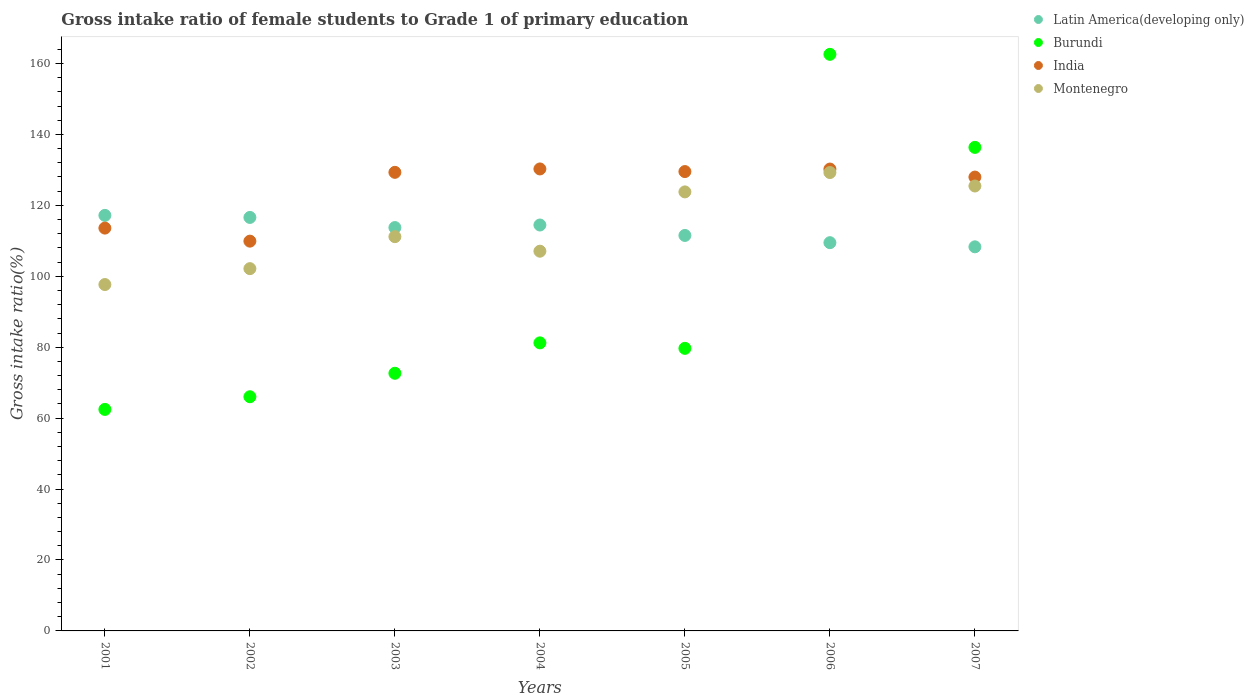What is the gross intake ratio in Burundi in 2007?
Ensure brevity in your answer.  136.34. Across all years, what is the maximum gross intake ratio in Montenegro?
Make the answer very short. 129.25. Across all years, what is the minimum gross intake ratio in Burundi?
Make the answer very short. 62.46. In which year was the gross intake ratio in Latin America(developing only) maximum?
Provide a short and direct response. 2001. In which year was the gross intake ratio in Burundi minimum?
Ensure brevity in your answer.  2001. What is the total gross intake ratio in Burundi in the graph?
Your answer should be very brief. 660.93. What is the difference between the gross intake ratio in India in 2005 and that in 2007?
Offer a terse response. 1.55. What is the difference between the gross intake ratio in Montenegro in 2006 and the gross intake ratio in Burundi in 2005?
Your response must be concise. 49.57. What is the average gross intake ratio in Montenegro per year?
Your answer should be very brief. 113.79. In the year 2001, what is the difference between the gross intake ratio in Montenegro and gross intake ratio in India?
Keep it short and to the point. -15.91. What is the ratio of the gross intake ratio in Montenegro in 2001 to that in 2004?
Offer a terse response. 0.91. Is the difference between the gross intake ratio in Montenegro in 2002 and 2006 greater than the difference between the gross intake ratio in India in 2002 and 2006?
Offer a very short reply. No. What is the difference between the highest and the second highest gross intake ratio in India?
Your answer should be very brief. 0.03. What is the difference between the highest and the lowest gross intake ratio in Latin America(developing only)?
Offer a very short reply. 8.87. In how many years, is the gross intake ratio in Montenegro greater than the average gross intake ratio in Montenegro taken over all years?
Provide a succinct answer. 3. Is the sum of the gross intake ratio in Burundi in 2002 and 2005 greater than the maximum gross intake ratio in Latin America(developing only) across all years?
Ensure brevity in your answer.  Yes. Is it the case that in every year, the sum of the gross intake ratio in Montenegro and gross intake ratio in Burundi  is greater than the gross intake ratio in Latin America(developing only)?
Offer a very short reply. Yes. Does the gross intake ratio in India monotonically increase over the years?
Your response must be concise. No. Is the gross intake ratio in Latin America(developing only) strictly less than the gross intake ratio in Montenegro over the years?
Make the answer very short. No. Are the values on the major ticks of Y-axis written in scientific E-notation?
Make the answer very short. No. Does the graph contain any zero values?
Your answer should be compact. No. How many legend labels are there?
Keep it short and to the point. 4. How are the legend labels stacked?
Your answer should be very brief. Vertical. What is the title of the graph?
Offer a terse response. Gross intake ratio of female students to Grade 1 of primary education. What is the label or title of the X-axis?
Offer a terse response. Years. What is the label or title of the Y-axis?
Your response must be concise. Gross intake ratio(%). What is the Gross intake ratio(%) in Latin America(developing only) in 2001?
Your answer should be very brief. 117.17. What is the Gross intake ratio(%) of Burundi in 2001?
Provide a short and direct response. 62.46. What is the Gross intake ratio(%) of India in 2001?
Provide a succinct answer. 113.58. What is the Gross intake ratio(%) in Montenegro in 2001?
Your answer should be very brief. 97.66. What is the Gross intake ratio(%) of Latin America(developing only) in 2002?
Provide a succinct answer. 116.59. What is the Gross intake ratio(%) of Burundi in 2002?
Ensure brevity in your answer.  66.03. What is the Gross intake ratio(%) in India in 2002?
Offer a terse response. 109.9. What is the Gross intake ratio(%) of Montenegro in 2002?
Give a very brief answer. 102.15. What is the Gross intake ratio(%) in Latin America(developing only) in 2003?
Provide a succinct answer. 113.73. What is the Gross intake ratio(%) in Burundi in 2003?
Offer a very short reply. 72.65. What is the Gross intake ratio(%) of India in 2003?
Give a very brief answer. 129.3. What is the Gross intake ratio(%) in Montenegro in 2003?
Make the answer very short. 111.16. What is the Gross intake ratio(%) in Latin America(developing only) in 2004?
Ensure brevity in your answer.  114.45. What is the Gross intake ratio(%) in Burundi in 2004?
Ensure brevity in your answer.  81.22. What is the Gross intake ratio(%) in India in 2004?
Give a very brief answer. 130.26. What is the Gross intake ratio(%) in Montenegro in 2004?
Ensure brevity in your answer.  107.06. What is the Gross intake ratio(%) in Latin America(developing only) in 2005?
Your answer should be very brief. 111.51. What is the Gross intake ratio(%) in Burundi in 2005?
Provide a short and direct response. 79.67. What is the Gross intake ratio(%) of India in 2005?
Provide a succinct answer. 129.52. What is the Gross intake ratio(%) in Montenegro in 2005?
Make the answer very short. 123.79. What is the Gross intake ratio(%) of Latin America(developing only) in 2006?
Your answer should be compact. 109.47. What is the Gross intake ratio(%) in Burundi in 2006?
Your answer should be compact. 162.58. What is the Gross intake ratio(%) in India in 2006?
Your answer should be very brief. 130.23. What is the Gross intake ratio(%) in Montenegro in 2006?
Your answer should be compact. 129.25. What is the Gross intake ratio(%) in Latin America(developing only) in 2007?
Ensure brevity in your answer.  108.3. What is the Gross intake ratio(%) in Burundi in 2007?
Your answer should be compact. 136.34. What is the Gross intake ratio(%) of India in 2007?
Your answer should be very brief. 127.97. What is the Gross intake ratio(%) in Montenegro in 2007?
Make the answer very short. 125.45. Across all years, what is the maximum Gross intake ratio(%) in Latin America(developing only)?
Your response must be concise. 117.17. Across all years, what is the maximum Gross intake ratio(%) of Burundi?
Offer a very short reply. 162.58. Across all years, what is the maximum Gross intake ratio(%) in India?
Ensure brevity in your answer.  130.26. Across all years, what is the maximum Gross intake ratio(%) in Montenegro?
Make the answer very short. 129.25. Across all years, what is the minimum Gross intake ratio(%) in Latin America(developing only)?
Your answer should be very brief. 108.3. Across all years, what is the minimum Gross intake ratio(%) in Burundi?
Make the answer very short. 62.46. Across all years, what is the minimum Gross intake ratio(%) of India?
Give a very brief answer. 109.9. Across all years, what is the minimum Gross intake ratio(%) of Montenegro?
Offer a very short reply. 97.66. What is the total Gross intake ratio(%) of Latin America(developing only) in the graph?
Offer a terse response. 791.21. What is the total Gross intake ratio(%) in Burundi in the graph?
Provide a succinct answer. 660.93. What is the total Gross intake ratio(%) in India in the graph?
Provide a succinct answer. 870.75. What is the total Gross intake ratio(%) of Montenegro in the graph?
Make the answer very short. 796.52. What is the difference between the Gross intake ratio(%) in Latin America(developing only) in 2001 and that in 2002?
Offer a terse response. 0.58. What is the difference between the Gross intake ratio(%) of Burundi in 2001 and that in 2002?
Provide a succinct answer. -3.57. What is the difference between the Gross intake ratio(%) in India in 2001 and that in 2002?
Ensure brevity in your answer.  3.68. What is the difference between the Gross intake ratio(%) of Montenegro in 2001 and that in 2002?
Your response must be concise. -4.48. What is the difference between the Gross intake ratio(%) of Latin America(developing only) in 2001 and that in 2003?
Your response must be concise. 3.44. What is the difference between the Gross intake ratio(%) in Burundi in 2001 and that in 2003?
Give a very brief answer. -10.19. What is the difference between the Gross intake ratio(%) of India in 2001 and that in 2003?
Keep it short and to the point. -15.72. What is the difference between the Gross intake ratio(%) of Montenegro in 2001 and that in 2003?
Give a very brief answer. -13.5. What is the difference between the Gross intake ratio(%) in Latin America(developing only) in 2001 and that in 2004?
Your response must be concise. 2.71. What is the difference between the Gross intake ratio(%) in Burundi in 2001 and that in 2004?
Provide a short and direct response. -18.76. What is the difference between the Gross intake ratio(%) in India in 2001 and that in 2004?
Your answer should be compact. -16.68. What is the difference between the Gross intake ratio(%) in Montenegro in 2001 and that in 2004?
Your answer should be very brief. -9.4. What is the difference between the Gross intake ratio(%) of Latin America(developing only) in 2001 and that in 2005?
Give a very brief answer. 5.66. What is the difference between the Gross intake ratio(%) of Burundi in 2001 and that in 2005?
Keep it short and to the point. -17.22. What is the difference between the Gross intake ratio(%) of India in 2001 and that in 2005?
Your answer should be compact. -15.94. What is the difference between the Gross intake ratio(%) in Montenegro in 2001 and that in 2005?
Your response must be concise. -26.12. What is the difference between the Gross intake ratio(%) of Latin America(developing only) in 2001 and that in 2006?
Offer a very short reply. 7.69. What is the difference between the Gross intake ratio(%) of Burundi in 2001 and that in 2006?
Give a very brief answer. -100.12. What is the difference between the Gross intake ratio(%) in India in 2001 and that in 2006?
Give a very brief answer. -16.65. What is the difference between the Gross intake ratio(%) of Montenegro in 2001 and that in 2006?
Your answer should be very brief. -31.58. What is the difference between the Gross intake ratio(%) in Latin America(developing only) in 2001 and that in 2007?
Provide a succinct answer. 8.87. What is the difference between the Gross intake ratio(%) in Burundi in 2001 and that in 2007?
Give a very brief answer. -73.88. What is the difference between the Gross intake ratio(%) of India in 2001 and that in 2007?
Provide a short and direct response. -14.39. What is the difference between the Gross intake ratio(%) in Montenegro in 2001 and that in 2007?
Your answer should be compact. -27.79. What is the difference between the Gross intake ratio(%) of Latin America(developing only) in 2002 and that in 2003?
Make the answer very short. 2.86. What is the difference between the Gross intake ratio(%) in Burundi in 2002 and that in 2003?
Keep it short and to the point. -6.62. What is the difference between the Gross intake ratio(%) of India in 2002 and that in 2003?
Give a very brief answer. -19.4. What is the difference between the Gross intake ratio(%) of Montenegro in 2002 and that in 2003?
Offer a very short reply. -9.02. What is the difference between the Gross intake ratio(%) in Latin America(developing only) in 2002 and that in 2004?
Provide a succinct answer. 2.13. What is the difference between the Gross intake ratio(%) of Burundi in 2002 and that in 2004?
Provide a short and direct response. -15.19. What is the difference between the Gross intake ratio(%) in India in 2002 and that in 2004?
Make the answer very short. -20.36. What is the difference between the Gross intake ratio(%) of Montenegro in 2002 and that in 2004?
Provide a succinct answer. -4.92. What is the difference between the Gross intake ratio(%) in Latin America(developing only) in 2002 and that in 2005?
Keep it short and to the point. 5.08. What is the difference between the Gross intake ratio(%) of Burundi in 2002 and that in 2005?
Provide a short and direct response. -13.65. What is the difference between the Gross intake ratio(%) of India in 2002 and that in 2005?
Provide a succinct answer. -19.62. What is the difference between the Gross intake ratio(%) in Montenegro in 2002 and that in 2005?
Ensure brevity in your answer.  -21.64. What is the difference between the Gross intake ratio(%) of Latin America(developing only) in 2002 and that in 2006?
Make the answer very short. 7.12. What is the difference between the Gross intake ratio(%) in Burundi in 2002 and that in 2006?
Make the answer very short. -96.55. What is the difference between the Gross intake ratio(%) in India in 2002 and that in 2006?
Keep it short and to the point. -20.33. What is the difference between the Gross intake ratio(%) of Montenegro in 2002 and that in 2006?
Offer a terse response. -27.1. What is the difference between the Gross intake ratio(%) of Latin America(developing only) in 2002 and that in 2007?
Provide a short and direct response. 8.29. What is the difference between the Gross intake ratio(%) in Burundi in 2002 and that in 2007?
Provide a succinct answer. -70.31. What is the difference between the Gross intake ratio(%) in India in 2002 and that in 2007?
Provide a succinct answer. -18.07. What is the difference between the Gross intake ratio(%) of Montenegro in 2002 and that in 2007?
Ensure brevity in your answer.  -23.3. What is the difference between the Gross intake ratio(%) of Latin America(developing only) in 2003 and that in 2004?
Keep it short and to the point. -0.72. What is the difference between the Gross intake ratio(%) of Burundi in 2003 and that in 2004?
Keep it short and to the point. -8.57. What is the difference between the Gross intake ratio(%) in India in 2003 and that in 2004?
Make the answer very short. -0.96. What is the difference between the Gross intake ratio(%) in Montenegro in 2003 and that in 2004?
Your response must be concise. 4.1. What is the difference between the Gross intake ratio(%) of Latin America(developing only) in 2003 and that in 2005?
Provide a short and direct response. 2.22. What is the difference between the Gross intake ratio(%) of Burundi in 2003 and that in 2005?
Offer a very short reply. -7.03. What is the difference between the Gross intake ratio(%) of India in 2003 and that in 2005?
Make the answer very short. -0.22. What is the difference between the Gross intake ratio(%) in Montenegro in 2003 and that in 2005?
Your answer should be compact. -12.62. What is the difference between the Gross intake ratio(%) of Latin America(developing only) in 2003 and that in 2006?
Ensure brevity in your answer.  4.26. What is the difference between the Gross intake ratio(%) in Burundi in 2003 and that in 2006?
Provide a succinct answer. -89.93. What is the difference between the Gross intake ratio(%) in India in 2003 and that in 2006?
Offer a very short reply. -0.93. What is the difference between the Gross intake ratio(%) in Montenegro in 2003 and that in 2006?
Keep it short and to the point. -18.08. What is the difference between the Gross intake ratio(%) in Latin America(developing only) in 2003 and that in 2007?
Keep it short and to the point. 5.43. What is the difference between the Gross intake ratio(%) in Burundi in 2003 and that in 2007?
Give a very brief answer. -63.69. What is the difference between the Gross intake ratio(%) of India in 2003 and that in 2007?
Your response must be concise. 1.34. What is the difference between the Gross intake ratio(%) in Montenegro in 2003 and that in 2007?
Offer a very short reply. -14.29. What is the difference between the Gross intake ratio(%) of Latin America(developing only) in 2004 and that in 2005?
Make the answer very short. 2.94. What is the difference between the Gross intake ratio(%) of Burundi in 2004 and that in 2005?
Give a very brief answer. 1.55. What is the difference between the Gross intake ratio(%) in India in 2004 and that in 2005?
Give a very brief answer. 0.74. What is the difference between the Gross intake ratio(%) of Montenegro in 2004 and that in 2005?
Offer a terse response. -16.72. What is the difference between the Gross intake ratio(%) in Latin America(developing only) in 2004 and that in 2006?
Provide a succinct answer. 4.98. What is the difference between the Gross intake ratio(%) of Burundi in 2004 and that in 2006?
Provide a short and direct response. -81.36. What is the difference between the Gross intake ratio(%) of India in 2004 and that in 2006?
Offer a terse response. 0.03. What is the difference between the Gross intake ratio(%) in Montenegro in 2004 and that in 2006?
Ensure brevity in your answer.  -22.18. What is the difference between the Gross intake ratio(%) in Latin America(developing only) in 2004 and that in 2007?
Keep it short and to the point. 6.15. What is the difference between the Gross intake ratio(%) of Burundi in 2004 and that in 2007?
Give a very brief answer. -55.12. What is the difference between the Gross intake ratio(%) in India in 2004 and that in 2007?
Your response must be concise. 2.29. What is the difference between the Gross intake ratio(%) of Montenegro in 2004 and that in 2007?
Keep it short and to the point. -18.39. What is the difference between the Gross intake ratio(%) of Latin America(developing only) in 2005 and that in 2006?
Your answer should be compact. 2.04. What is the difference between the Gross intake ratio(%) in Burundi in 2005 and that in 2006?
Provide a short and direct response. -82.9. What is the difference between the Gross intake ratio(%) of India in 2005 and that in 2006?
Ensure brevity in your answer.  -0.71. What is the difference between the Gross intake ratio(%) of Montenegro in 2005 and that in 2006?
Provide a short and direct response. -5.46. What is the difference between the Gross intake ratio(%) in Latin America(developing only) in 2005 and that in 2007?
Give a very brief answer. 3.21. What is the difference between the Gross intake ratio(%) in Burundi in 2005 and that in 2007?
Your answer should be compact. -56.67. What is the difference between the Gross intake ratio(%) of India in 2005 and that in 2007?
Your answer should be very brief. 1.55. What is the difference between the Gross intake ratio(%) of Montenegro in 2005 and that in 2007?
Keep it short and to the point. -1.66. What is the difference between the Gross intake ratio(%) of Latin America(developing only) in 2006 and that in 2007?
Provide a short and direct response. 1.17. What is the difference between the Gross intake ratio(%) of Burundi in 2006 and that in 2007?
Offer a very short reply. 26.24. What is the difference between the Gross intake ratio(%) in India in 2006 and that in 2007?
Offer a very short reply. 2.26. What is the difference between the Gross intake ratio(%) in Montenegro in 2006 and that in 2007?
Provide a succinct answer. 3.8. What is the difference between the Gross intake ratio(%) of Latin America(developing only) in 2001 and the Gross intake ratio(%) of Burundi in 2002?
Offer a very short reply. 51.14. What is the difference between the Gross intake ratio(%) in Latin America(developing only) in 2001 and the Gross intake ratio(%) in India in 2002?
Provide a succinct answer. 7.27. What is the difference between the Gross intake ratio(%) in Latin America(developing only) in 2001 and the Gross intake ratio(%) in Montenegro in 2002?
Provide a short and direct response. 15.02. What is the difference between the Gross intake ratio(%) in Burundi in 2001 and the Gross intake ratio(%) in India in 2002?
Your answer should be compact. -47.44. What is the difference between the Gross intake ratio(%) of Burundi in 2001 and the Gross intake ratio(%) of Montenegro in 2002?
Ensure brevity in your answer.  -39.69. What is the difference between the Gross intake ratio(%) in India in 2001 and the Gross intake ratio(%) in Montenegro in 2002?
Give a very brief answer. 11.43. What is the difference between the Gross intake ratio(%) in Latin America(developing only) in 2001 and the Gross intake ratio(%) in Burundi in 2003?
Your answer should be compact. 44.52. What is the difference between the Gross intake ratio(%) in Latin America(developing only) in 2001 and the Gross intake ratio(%) in India in 2003?
Your answer should be compact. -12.14. What is the difference between the Gross intake ratio(%) of Latin America(developing only) in 2001 and the Gross intake ratio(%) of Montenegro in 2003?
Offer a terse response. 6. What is the difference between the Gross intake ratio(%) of Burundi in 2001 and the Gross intake ratio(%) of India in 2003?
Make the answer very short. -66.85. What is the difference between the Gross intake ratio(%) in Burundi in 2001 and the Gross intake ratio(%) in Montenegro in 2003?
Offer a terse response. -48.71. What is the difference between the Gross intake ratio(%) in India in 2001 and the Gross intake ratio(%) in Montenegro in 2003?
Provide a short and direct response. 2.42. What is the difference between the Gross intake ratio(%) of Latin America(developing only) in 2001 and the Gross intake ratio(%) of Burundi in 2004?
Offer a very short reply. 35.95. What is the difference between the Gross intake ratio(%) of Latin America(developing only) in 2001 and the Gross intake ratio(%) of India in 2004?
Offer a very short reply. -13.09. What is the difference between the Gross intake ratio(%) in Latin America(developing only) in 2001 and the Gross intake ratio(%) in Montenegro in 2004?
Ensure brevity in your answer.  10.1. What is the difference between the Gross intake ratio(%) of Burundi in 2001 and the Gross intake ratio(%) of India in 2004?
Offer a very short reply. -67.8. What is the difference between the Gross intake ratio(%) in Burundi in 2001 and the Gross intake ratio(%) in Montenegro in 2004?
Make the answer very short. -44.61. What is the difference between the Gross intake ratio(%) in India in 2001 and the Gross intake ratio(%) in Montenegro in 2004?
Your answer should be compact. 6.51. What is the difference between the Gross intake ratio(%) of Latin America(developing only) in 2001 and the Gross intake ratio(%) of Burundi in 2005?
Provide a short and direct response. 37.49. What is the difference between the Gross intake ratio(%) in Latin America(developing only) in 2001 and the Gross intake ratio(%) in India in 2005?
Provide a succinct answer. -12.35. What is the difference between the Gross intake ratio(%) of Latin America(developing only) in 2001 and the Gross intake ratio(%) of Montenegro in 2005?
Keep it short and to the point. -6.62. What is the difference between the Gross intake ratio(%) of Burundi in 2001 and the Gross intake ratio(%) of India in 2005?
Offer a terse response. -67.06. What is the difference between the Gross intake ratio(%) of Burundi in 2001 and the Gross intake ratio(%) of Montenegro in 2005?
Keep it short and to the point. -61.33. What is the difference between the Gross intake ratio(%) in India in 2001 and the Gross intake ratio(%) in Montenegro in 2005?
Your answer should be compact. -10.21. What is the difference between the Gross intake ratio(%) in Latin America(developing only) in 2001 and the Gross intake ratio(%) in Burundi in 2006?
Your answer should be compact. -45.41. What is the difference between the Gross intake ratio(%) of Latin America(developing only) in 2001 and the Gross intake ratio(%) of India in 2006?
Your answer should be compact. -13.06. What is the difference between the Gross intake ratio(%) in Latin America(developing only) in 2001 and the Gross intake ratio(%) in Montenegro in 2006?
Your answer should be compact. -12.08. What is the difference between the Gross intake ratio(%) in Burundi in 2001 and the Gross intake ratio(%) in India in 2006?
Your response must be concise. -67.77. What is the difference between the Gross intake ratio(%) in Burundi in 2001 and the Gross intake ratio(%) in Montenegro in 2006?
Your response must be concise. -66.79. What is the difference between the Gross intake ratio(%) in India in 2001 and the Gross intake ratio(%) in Montenegro in 2006?
Your answer should be very brief. -15.67. What is the difference between the Gross intake ratio(%) in Latin America(developing only) in 2001 and the Gross intake ratio(%) in Burundi in 2007?
Provide a succinct answer. -19.17. What is the difference between the Gross intake ratio(%) in Latin America(developing only) in 2001 and the Gross intake ratio(%) in India in 2007?
Offer a very short reply. -10.8. What is the difference between the Gross intake ratio(%) in Latin America(developing only) in 2001 and the Gross intake ratio(%) in Montenegro in 2007?
Give a very brief answer. -8.28. What is the difference between the Gross intake ratio(%) of Burundi in 2001 and the Gross intake ratio(%) of India in 2007?
Keep it short and to the point. -65.51. What is the difference between the Gross intake ratio(%) of Burundi in 2001 and the Gross intake ratio(%) of Montenegro in 2007?
Make the answer very short. -62.99. What is the difference between the Gross intake ratio(%) in India in 2001 and the Gross intake ratio(%) in Montenegro in 2007?
Keep it short and to the point. -11.87. What is the difference between the Gross intake ratio(%) of Latin America(developing only) in 2002 and the Gross intake ratio(%) of Burundi in 2003?
Make the answer very short. 43.94. What is the difference between the Gross intake ratio(%) of Latin America(developing only) in 2002 and the Gross intake ratio(%) of India in 2003?
Offer a terse response. -12.72. What is the difference between the Gross intake ratio(%) in Latin America(developing only) in 2002 and the Gross intake ratio(%) in Montenegro in 2003?
Provide a short and direct response. 5.42. What is the difference between the Gross intake ratio(%) of Burundi in 2002 and the Gross intake ratio(%) of India in 2003?
Your answer should be compact. -63.28. What is the difference between the Gross intake ratio(%) in Burundi in 2002 and the Gross intake ratio(%) in Montenegro in 2003?
Make the answer very short. -45.14. What is the difference between the Gross intake ratio(%) of India in 2002 and the Gross intake ratio(%) of Montenegro in 2003?
Make the answer very short. -1.26. What is the difference between the Gross intake ratio(%) of Latin America(developing only) in 2002 and the Gross intake ratio(%) of Burundi in 2004?
Ensure brevity in your answer.  35.37. What is the difference between the Gross intake ratio(%) of Latin America(developing only) in 2002 and the Gross intake ratio(%) of India in 2004?
Your answer should be very brief. -13.67. What is the difference between the Gross intake ratio(%) of Latin America(developing only) in 2002 and the Gross intake ratio(%) of Montenegro in 2004?
Offer a terse response. 9.52. What is the difference between the Gross intake ratio(%) in Burundi in 2002 and the Gross intake ratio(%) in India in 2004?
Keep it short and to the point. -64.23. What is the difference between the Gross intake ratio(%) in Burundi in 2002 and the Gross intake ratio(%) in Montenegro in 2004?
Offer a terse response. -41.04. What is the difference between the Gross intake ratio(%) of India in 2002 and the Gross intake ratio(%) of Montenegro in 2004?
Make the answer very short. 2.84. What is the difference between the Gross intake ratio(%) of Latin America(developing only) in 2002 and the Gross intake ratio(%) of Burundi in 2005?
Your answer should be very brief. 36.91. What is the difference between the Gross intake ratio(%) in Latin America(developing only) in 2002 and the Gross intake ratio(%) in India in 2005?
Offer a terse response. -12.93. What is the difference between the Gross intake ratio(%) in Latin America(developing only) in 2002 and the Gross intake ratio(%) in Montenegro in 2005?
Your response must be concise. -7.2. What is the difference between the Gross intake ratio(%) in Burundi in 2002 and the Gross intake ratio(%) in India in 2005?
Give a very brief answer. -63.49. What is the difference between the Gross intake ratio(%) of Burundi in 2002 and the Gross intake ratio(%) of Montenegro in 2005?
Your response must be concise. -57.76. What is the difference between the Gross intake ratio(%) in India in 2002 and the Gross intake ratio(%) in Montenegro in 2005?
Your answer should be very brief. -13.89. What is the difference between the Gross intake ratio(%) in Latin America(developing only) in 2002 and the Gross intake ratio(%) in Burundi in 2006?
Your answer should be very brief. -45.99. What is the difference between the Gross intake ratio(%) of Latin America(developing only) in 2002 and the Gross intake ratio(%) of India in 2006?
Your answer should be very brief. -13.64. What is the difference between the Gross intake ratio(%) in Latin America(developing only) in 2002 and the Gross intake ratio(%) in Montenegro in 2006?
Offer a terse response. -12.66. What is the difference between the Gross intake ratio(%) of Burundi in 2002 and the Gross intake ratio(%) of India in 2006?
Offer a very short reply. -64.2. What is the difference between the Gross intake ratio(%) in Burundi in 2002 and the Gross intake ratio(%) in Montenegro in 2006?
Give a very brief answer. -63.22. What is the difference between the Gross intake ratio(%) in India in 2002 and the Gross intake ratio(%) in Montenegro in 2006?
Your answer should be compact. -19.35. What is the difference between the Gross intake ratio(%) of Latin America(developing only) in 2002 and the Gross intake ratio(%) of Burundi in 2007?
Offer a very short reply. -19.75. What is the difference between the Gross intake ratio(%) in Latin America(developing only) in 2002 and the Gross intake ratio(%) in India in 2007?
Offer a terse response. -11.38. What is the difference between the Gross intake ratio(%) of Latin America(developing only) in 2002 and the Gross intake ratio(%) of Montenegro in 2007?
Your response must be concise. -8.86. What is the difference between the Gross intake ratio(%) of Burundi in 2002 and the Gross intake ratio(%) of India in 2007?
Give a very brief answer. -61.94. What is the difference between the Gross intake ratio(%) in Burundi in 2002 and the Gross intake ratio(%) in Montenegro in 2007?
Your answer should be very brief. -59.42. What is the difference between the Gross intake ratio(%) of India in 2002 and the Gross intake ratio(%) of Montenegro in 2007?
Offer a terse response. -15.55. What is the difference between the Gross intake ratio(%) of Latin America(developing only) in 2003 and the Gross intake ratio(%) of Burundi in 2004?
Your answer should be compact. 32.51. What is the difference between the Gross intake ratio(%) in Latin America(developing only) in 2003 and the Gross intake ratio(%) in India in 2004?
Give a very brief answer. -16.53. What is the difference between the Gross intake ratio(%) in Latin America(developing only) in 2003 and the Gross intake ratio(%) in Montenegro in 2004?
Your answer should be very brief. 6.67. What is the difference between the Gross intake ratio(%) of Burundi in 2003 and the Gross intake ratio(%) of India in 2004?
Your answer should be very brief. -57.61. What is the difference between the Gross intake ratio(%) of Burundi in 2003 and the Gross intake ratio(%) of Montenegro in 2004?
Your answer should be compact. -34.42. What is the difference between the Gross intake ratio(%) of India in 2003 and the Gross intake ratio(%) of Montenegro in 2004?
Ensure brevity in your answer.  22.24. What is the difference between the Gross intake ratio(%) in Latin America(developing only) in 2003 and the Gross intake ratio(%) in Burundi in 2005?
Provide a succinct answer. 34.06. What is the difference between the Gross intake ratio(%) in Latin America(developing only) in 2003 and the Gross intake ratio(%) in India in 2005?
Offer a very short reply. -15.79. What is the difference between the Gross intake ratio(%) of Latin America(developing only) in 2003 and the Gross intake ratio(%) of Montenegro in 2005?
Offer a very short reply. -10.06. What is the difference between the Gross intake ratio(%) of Burundi in 2003 and the Gross intake ratio(%) of India in 2005?
Provide a succinct answer. -56.87. What is the difference between the Gross intake ratio(%) in Burundi in 2003 and the Gross intake ratio(%) in Montenegro in 2005?
Ensure brevity in your answer.  -51.14. What is the difference between the Gross intake ratio(%) of India in 2003 and the Gross intake ratio(%) of Montenegro in 2005?
Make the answer very short. 5.52. What is the difference between the Gross intake ratio(%) of Latin America(developing only) in 2003 and the Gross intake ratio(%) of Burundi in 2006?
Provide a short and direct response. -48.85. What is the difference between the Gross intake ratio(%) of Latin America(developing only) in 2003 and the Gross intake ratio(%) of India in 2006?
Provide a succinct answer. -16.5. What is the difference between the Gross intake ratio(%) of Latin America(developing only) in 2003 and the Gross intake ratio(%) of Montenegro in 2006?
Offer a terse response. -15.52. What is the difference between the Gross intake ratio(%) of Burundi in 2003 and the Gross intake ratio(%) of India in 2006?
Your response must be concise. -57.58. What is the difference between the Gross intake ratio(%) of Burundi in 2003 and the Gross intake ratio(%) of Montenegro in 2006?
Make the answer very short. -56.6. What is the difference between the Gross intake ratio(%) of India in 2003 and the Gross intake ratio(%) of Montenegro in 2006?
Give a very brief answer. 0.06. What is the difference between the Gross intake ratio(%) of Latin America(developing only) in 2003 and the Gross intake ratio(%) of Burundi in 2007?
Keep it short and to the point. -22.61. What is the difference between the Gross intake ratio(%) of Latin America(developing only) in 2003 and the Gross intake ratio(%) of India in 2007?
Your response must be concise. -14.24. What is the difference between the Gross intake ratio(%) of Latin America(developing only) in 2003 and the Gross intake ratio(%) of Montenegro in 2007?
Your response must be concise. -11.72. What is the difference between the Gross intake ratio(%) in Burundi in 2003 and the Gross intake ratio(%) in India in 2007?
Your answer should be very brief. -55.32. What is the difference between the Gross intake ratio(%) of Burundi in 2003 and the Gross intake ratio(%) of Montenegro in 2007?
Make the answer very short. -52.8. What is the difference between the Gross intake ratio(%) in India in 2003 and the Gross intake ratio(%) in Montenegro in 2007?
Give a very brief answer. 3.85. What is the difference between the Gross intake ratio(%) in Latin America(developing only) in 2004 and the Gross intake ratio(%) in Burundi in 2005?
Ensure brevity in your answer.  34.78. What is the difference between the Gross intake ratio(%) in Latin America(developing only) in 2004 and the Gross intake ratio(%) in India in 2005?
Offer a terse response. -15.07. What is the difference between the Gross intake ratio(%) in Latin America(developing only) in 2004 and the Gross intake ratio(%) in Montenegro in 2005?
Your answer should be compact. -9.34. What is the difference between the Gross intake ratio(%) of Burundi in 2004 and the Gross intake ratio(%) of India in 2005?
Your answer should be compact. -48.3. What is the difference between the Gross intake ratio(%) in Burundi in 2004 and the Gross intake ratio(%) in Montenegro in 2005?
Your answer should be compact. -42.57. What is the difference between the Gross intake ratio(%) of India in 2004 and the Gross intake ratio(%) of Montenegro in 2005?
Your answer should be very brief. 6.47. What is the difference between the Gross intake ratio(%) in Latin America(developing only) in 2004 and the Gross intake ratio(%) in Burundi in 2006?
Give a very brief answer. -48.12. What is the difference between the Gross intake ratio(%) of Latin America(developing only) in 2004 and the Gross intake ratio(%) of India in 2006?
Ensure brevity in your answer.  -15.78. What is the difference between the Gross intake ratio(%) in Latin America(developing only) in 2004 and the Gross intake ratio(%) in Montenegro in 2006?
Offer a very short reply. -14.79. What is the difference between the Gross intake ratio(%) in Burundi in 2004 and the Gross intake ratio(%) in India in 2006?
Provide a succinct answer. -49.01. What is the difference between the Gross intake ratio(%) in Burundi in 2004 and the Gross intake ratio(%) in Montenegro in 2006?
Your answer should be very brief. -48.03. What is the difference between the Gross intake ratio(%) of India in 2004 and the Gross intake ratio(%) of Montenegro in 2006?
Your answer should be compact. 1.01. What is the difference between the Gross intake ratio(%) of Latin America(developing only) in 2004 and the Gross intake ratio(%) of Burundi in 2007?
Offer a terse response. -21.89. What is the difference between the Gross intake ratio(%) of Latin America(developing only) in 2004 and the Gross intake ratio(%) of India in 2007?
Make the answer very short. -13.51. What is the difference between the Gross intake ratio(%) of Latin America(developing only) in 2004 and the Gross intake ratio(%) of Montenegro in 2007?
Provide a short and direct response. -11. What is the difference between the Gross intake ratio(%) of Burundi in 2004 and the Gross intake ratio(%) of India in 2007?
Your answer should be very brief. -46.75. What is the difference between the Gross intake ratio(%) of Burundi in 2004 and the Gross intake ratio(%) of Montenegro in 2007?
Make the answer very short. -44.23. What is the difference between the Gross intake ratio(%) of India in 2004 and the Gross intake ratio(%) of Montenegro in 2007?
Make the answer very short. 4.81. What is the difference between the Gross intake ratio(%) of Latin America(developing only) in 2005 and the Gross intake ratio(%) of Burundi in 2006?
Provide a short and direct response. -51.07. What is the difference between the Gross intake ratio(%) of Latin America(developing only) in 2005 and the Gross intake ratio(%) of India in 2006?
Keep it short and to the point. -18.72. What is the difference between the Gross intake ratio(%) in Latin America(developing only) in 2005 and the Gross intake ratio(%) in Montenegro in 2006?
Make the answer very short. -17.74. What is the difference between the Gross intake ratio(%) of Burundi in 2005 and the Gross intake ratio(%) of India in 2006?
Make the answer very short. -50.56. What is the difference between the Gross intake ratio(%) in Burundi in 2005 and the Gross intake ratio(%) in Montenegro in 2006?
Provide a short and direct response. -49.57. What is the difference between the Gross intake ratio(%) of India in 2005 and the Gross intake ratio(%) of Montenegro in 2006?
Provide a short and direct response. 0.27. What is the difference between the Gross intake ratio(%) of Latin America(developing only) in 2005 and the Gross intake ratio(%) of Burundi in 2007?
Give a very brief answer. -24.83. What is the difference between the Gross intake ratio(%) of Latin America(developing only) in 2005 and the Gross intake ratio(%) of India in 2007?
Provide a succinct answer. -16.46. What is the difference between the Gross intake ratio(%) of Latin America(developing only) in 2005 and the Gross intake ratio(%) of Montenegro in 2007?
Your answer should be very brief. -13.94. What is the difference between the Gross intake ratio(%) of Burundi in 2005 and the Gross intake ratio(%) of India in 2007?
Give a very brief answer. -48.29. What is the difference between the Gross intake ratio(%) in Burundi in 2005 and the Gross intake ratio(%) in Montenegro in 2007?
Ensure brevity in your answer.  -45.78. What is the difference between the Gross intake ratio(%) of India in 2005 and the Gross intake ratio(%) of Montenegro in 2007?
Make the answer very short. 4.07. What is the difference between the Gross intake ratio(%) in Latin America(developing only) in 2006 and the Gross intake ratio(%) in Burundi in 2007?
Give a very brief answer. -26.87. What is the difference between the Gross intake ratio(%) of Latin America(developing only) in 2006 and the Gross intake ratio(%) of India in 2007?
Provide a short and direct response. -18.5. What is the difference between the Gross intake ratio(%) in Latin America(developing only) in 2006 and the Gross intake ratio(%) in Montenegro in 2007?
Offer a very short reply. -15.98. What is the difference between the Gross intake ratio(%) of Burundi in 2006 and the Gross intake ratio(%) of India in 2007?
Ensure brevity in your answer.  34.61. What is the difference between the Gross intake ratio(%) of Burundi in 2006 and the Gross intake ratio(%) of Montenegro in 2007?
Keep it short and to the point. 37.13. What is the difference between the Gross intake ratio(%) in India in 2006 and the Gross intake ratio(%) in Montenegro in 2007?
Your response must be concise. 4.78. What is the average Gross intake ratio(%) in Latin America(developing only) per year?
Your response must be concise. 113.03. What is the average Gross intake ratio(%) of Burundi per year?
Offer a very short reply. 94.42. What is the average Gross intake ratio(%) of India per year?
Your response must be concise. 124.39. What is the average Gross intake ratio(%) of Montenegro per year?
Keep it short and to the point. 113.79. In the year 2001, what is the difference between the Gross intake ratio(%) of Latin America(developing only) and Gross intake ratio(%) of Burundi?
Provide a short and direct response. 54.71. In the year 2001, what is the difference between the Gross intake ratio(%) of Latin America(developing only) and Gross intake ratio(%) of India?
Make the answer very short. 3.59. In the year 2001, what is the difference between the Gross intake ratio(%) in Latin America(developing only) and Gross intake ratio(%) in Montenegro?
Offer a very short reply. 19.5. In the year 2001, what is the difference between the Gross intake ratio(%) of Burundi and Gross intake ratio(%) of India?
Provide a short and direct response. -51.12. In the year 2001, what is the difference between the Gross intake ratio(%) in Burundi and Gross intake ratio(%) in Montenegro?
Keep it short and to the point. -35.21. In the year 2001, what is the difference between the Gross intake ratio(%) in India and Gross intake ratio(%) in Montenegro?
Give a very brief answer. 15.91. In the year 2002, what is the difference between the Gross intake ratio(%) of Latin America(developing only) and Gross intake ratio(%) of Burundi?
Provide a short and direct response. 50.56. In the year 2002, what is the difference between the Gross intake ratio(%) in Latin America(developing only) and Gross intake ratio(%) in India?
Your answer should be very brief. 6.69. In the year 2002, what is the difference between the Gross intake ratio(%) of Latin America(developing only) and Gross intake ratio(%) of Montenegro?
Offer a terse response. 14.44. In the year 2002, what is the difference between the Gross intake ratio(%) of Burundi and Gross intake ratio(%) of India?
Keep it short and to the point. -43.87. In the year 2002, what is the difference between the Gross intake ratio(%) in Burundi and Gross intake ratio(%) in Montenegro?
Keep it short and to the point. -36.12. In the year 2002, what is the difference between the Gross intake ratio(%) of India and Gross intake ratio(%) of Montenegro?
Keep it short and to the point. 7.75. In the year 2003, what is the difference between the Gross intake ratio(%) of Latin America(developing only) and Gross intake ratio(%) of Burundi?
Ensure brevity in your answer.  41.08. In the year 2003, what is the difference between the Gross intake ratio(%) in Latin America(developing only) and Gross intake ratio(%) in India?
Your answer should be compact. -15.57. In the year 2003, what is the difference between the Gross intake ratio(%) of Latin America(developing only) and Gross intake ratio(%) of Montenegro?
Ensure brevity in your answer.  2.57. In the year 2003, what is the difference between the Gross intake ratio(%) in Burundi and Gross intake ratio(%) in India?
Ensure brevity in your answer.  -56.66. In the year 2003, what is the difference between the Gross intake ratio(%) of Burundi and Gross intake ratio(%) of Montenegro?
Your response must be concise. -38.52. In the year 2003, what is the difference between the Gross intake ratio(%) of India and Gross intake ratio(%) of Montenegro?
Your answer should be compact. 18.14. In the year 2004, what is the difference between the Gross intake ratio(%) of Latin America(developing only) and Gross intake ratio(%) of Burundi?
Give a very brief answer. 33.23. In the year 2004, what is the difference between the Gross intake ratio(%) of Latin America(developing only) and Gross intake ratio(%) of India?
Make the answer very short. -15.81. In the year 2004, what is the difference between the Gross intake ratio(%) of Latin America(developing only) and Gross intake ratio(%) of Montenegro?
Your answer should be very brief. 7.39. In the year 2004, what is the difference between the Gross intake ratio(%) of Burundi and Gross intake ratio(%) of India?
Your answer should be compact. -49.04. In the year 2004, what is the difference between the Gross intake ratio(%) of Burundi and Gross intake ratio(%) of Montenegro?
Provide a succinct answer. -25.85. In the year 2004, what is the difference between the Gross intake ratio(%) in India and Gross intake ratio(%) in Montenegro?
Keep it short and to the point. 23.19. In the year 2005, what is the difference between the Gross intake ratio(%) in Latin America(developing only) and Gross intake ratio(%) in Burundi?
Your answer should be very brief. 31.84. In the year 2005, what is the difference between the Gross intake ratio(%) of Latin America(developing only) and Gross intake ratio(%) of India?
Your answer should be very brief. -18.01. In the year 2005, what is the difference between the Gross intake ratio(%) in Latin America(developing only) and Gross intake ratio(%) in Montenegro?
Make the answer very short. -12.28. In the year 2005, what is the difference between the Gross intake ratio(%) of Burundi and Gross intake ratio(%) of India?
Keep it short and to the point. -49.85. In the year 2005, what is the difference between the Gross intake ratio(%) in Burundi and Gross intake ratio(%) in Montenegro?
Your answer should be very brief. -44.11. In the year 2005, what is the difference between the Gross intake ratio(%) in India and Gross intake ratio(%) in Montenegro?
Your answer should be compact. 5.73. In the year 2006, what is the difference between the Gross intake ratio(%) of Latin America(developing only) and Gross intake ratio(%) of Burundi?
Ensure brevity in your answer.  -53.11. In the year 2006, what is the difference between the Gross intake ratio(%) in Latin America(developing only) and Gross intake ratio(%) in India?
Your response must be concise. -20.76. In the year 2006, what is the difference between the Gross intake ratio(%) of Latin America(developing only) and Gross intake ratio(%) of Montenegro?
Offer a terse response. -19.78. In the year 2006, what is the difference between the Gross intake ratio(%) of Burundi and Gross intake ratio(%) of India?
Provide a short and direct response. 32.35. In the year 2006, what is the difference between the Gross intake ratio(%) in Burundi and Gross intake ratio(%) in Montenegro?
Ensure brevity in your answer.  33.33. In the year 2006, what is the difference between the Gross intake ratio(%) in India and Gross intake ratio(%) in Montenegro?
Ensure brevity in your answer.  0.98. In the year 2007, what is the difference between the Gross intake ratio(%) in Latin America(developing only) and Gross intake ratio(%) in Burundi?
Your answer should be compact. -28.04. In the year 2007, what is the difference between the Gross intake ratio(%) of Latin America(developing only) and Gross intake ratio(%) of India?
Your answer should be very brief. -19.67. In the year 2007, what is the difference between the Gross intake ratio(%) of Latin America(developing only) and Gross intake ratio(%) of Montenegro?
Offer a very short reply. -17.15. In the year 2007, what is the difference between the Gross intake ratio(%) of Burundi and Gross intake ratio(%) of India?
Your answer should be very brief. 8.37. In the year 2007, what is the difference between the Gross intake ratio(%) of Burundi and Gross intake ratio(%) of Montenegro?
Offer a very short reply. 10.89. In the year 2007, what is the difference between the Gross intake ratio(%) in India and Gross intake ratio(%) in Montenegro?
Make the answer very short. 2.52. What is the ratio of the Gross intake ratio(%) in Burundi in 2001 to that in 2002?
Ensure brevity in your answer.  0.95. What is the ratio of the Gross intake ratio(%) of India in 2001 to that in 2002?
Offer a terse response. 1.03. What is the ratio of the Gross intake ratio(%) in Montenegro in 2001 to that in 2002?
Your response must be concise. 0.96. What is the ratio of the Gross intake ratio(%) in Latin America(developing only) in 2001 to that in 2003?
Give a very brief answer. 1.03. What is the ratio of the Gross intake ratio(%) of Burundi in 2001 to that in 2003?
Offer a terse response. 0.86. What is the ratio of the Gross intake ratio(%) in India in 2001 to that in 2003?
Keep it short and to the point. 0.88. What is the ratio of the Gross intake ratio(%) of Montenegro in 2001 to that in 2003?
Make the answer very short. 0.88. What is the ratio of the Gross intake ratio(%) in Latin America(developing only) in 2001 to that in 2004?
Provide a short and direct response. 1.02. What is the ratio of the Gross intake ratio(%) of Burundi in 2001 to that in 2004?
Provide a succinct answer. 0.77. What is the ratio of the Gross intake ratio(%) in India in 2001 to that in 2004?
Offer a very short reply. 0.87. What is the ratio of the Gross intake ratio(%) of Montenegro in 2001 to that in 2004?
Offer a very short reply. 0.91. What is the ratio of the Gross intake ratio(%) in Latin America(developing only) in 2001 to that in 2005?
Offer a very short reply. 1.05. What is the ratio of the Gross intake ratio(%) in Burundi in 2001 to that in 2005?
Provide a succinct answer. 0.78. What is the ratio of the Gross intake ratio(%) in India in 2001 to that in 2005?
Your answer should be compact. 0.88. What is the ratio of the Gross intake ratio(%) in Montenegro in 2001 to that in 2005?
Offer a terse response. 0.79. What is the ratio of the Gross intake ratio(%) of Latin America(developing only) in 2001 to that in 2006?
Make the answer very short. 1.07. What is the ratio of the Gross intake ratio(%) of Burundi in 2001 to that in 2006?
Offer a terse response. 0.38. What is the ratio of the Gross intake ratio(%) of India in 2001 to that in 2006?
Your answer should be very brief. 0.87. What is the ratio of the Gross intake ratio(%) of Montenegro in 2001 to that in 2006?
Offer a terse response. 0.76. What is the ratio of the Gross intake ratio(%) in Latin America(developing only) in 2001 to that in 2007?
Ensure brevity in your answer.  1.08. What is the ratio of the Gross intake ratio(%) of Burundi in 2001 to that in 2007?
Your answer should be very brief. 0.46. What is the ratio of the Gross intake ratio(%) in India in 2001 to that in 2007?
Offer a terse response. 0.89. What is the ratio of the Gross intake ratio(%) of Montenegro in 2001 to that in 2007?
Offer a very short reply. 0.78. What is the ratio of the Gross intake ratio(%) in Latin America(developing only) in 2002 to that in 2003?
Offer a terse response. 1.03. What is the ratio of the Gross intake ratio(%) of Burundi in 2002 to that in 2003?
Offer a terse response. 0.91. What is the ratio of the Gross intake ratio(%) in India in 2002 to that in 2003?
Offer a very short reply. 0.85. What is the ratio of the Gross intake ratio(%) in Montenegro in 2002 to that in 2003?
Offer a very short reply. 0.92. What is the ratio of the Gross intake ratio(%) in Latin America(developing only) in 2002 to that in 2004?
Provide a succinct answer. 1.02. What is the ratio of the Gross intake ratio(%) in Burundi in 2002 to that in 2004?
Provide a succinct answer. 0.81. What is the ratio of the Gross intake ratio(%) of India in 2002 to that in 2004?
Provide a succinct answer. 0.84. What is the ratio of the Gross intake ratio(%) of Montenegro in 2002 to that in 2004?
Ensure brevity in your answer.  0.95. What is the ratio of the Gross intake ratio(%) of Latin America(developing only) in 2002 to that in 2005?
Provide a succinct answer. 1.05. What is the ratio of the Gross intake ratio(%) of Burundi in 2002 to that in 2005?
Provide a succinct answer. 0.83. What is the ratio of the Gross intake ratio(%) of India in 2002 to that in 2005?
Give a very brief answer. 0.85. What is the ratio of the Gross intake ratio(%) of Montenegro in 2002 to that in 2005?
Keep it short and to the point. 0.83. What is the ratio of the Gross intake ratio(%) in Latin America(developing only) in 2002 to that in 2006?
Give a very brief answer. 1.06. What is the ratio of the Gross intake ratio(%) of Burundi in 2002 to that in 2006?
Your answer should be compact. 0.41. What is the ratio of the Gross intake ratio(%) in India in 2002 to that in 2006?
Make the answer very short. 0.84. What is the ratio of the Gross intake ratio(%) in Montenegro in 2002 to that in 2006?
Give a very brief answer. 0.79. What is the ratio of the Gross intake ratio(%) in Latin America(developing only) in 2002 to that in 2007?
Your answer should be very brief. 1.08. What is the ratio of the Gross intake ratio(%) of Burundi in 2002 to that in 2007?
Provide a short and direct response. 0.48. What is the ratio of the Gross intake ratio(%) in India in 2002 to that in 2007?
Keep it short and to the point. 0.86. What is the ratio of the Gross intake ratio(%) in Montenegro in 2002 to that in 2007?
Ensure brevity in your answer.  0.81. What is the ratio of the Gross intake ratio(%) of Latin America(developing only) in 2003 to that in 2004?
Keep it short and to the point. 0.99. What is the ratio of the Gross intake ratio(%) of Burundi in 2003 to that in 2004?
Give a very brief answer. 0.89. What is the ratio of the Gross intake ratio(%) of India in 2003 to that in 2004?
Give a very brief answer. 0.99. What is the ratio of the Gross intake ratio(%) of Montenegro in 2003 to that in 2004?
Make the answer very short. 1.04. What is the ratio of the Gross intake ratio(%) of Latin America(developing only) in 2003 to that in 2005?
Provide a succinct answer. 1.02. What is the ratio of the Gross intake ratio(%) in Burundi in 2003 to that in 2005?
Your response must be concise. 0.91. What is the ratio of the Gross intake ratio(%) in Montenegro in 2003 to that in 2005?
Ensure brevity in your answer.  0.9. What is the ratio of the Gross intake ratio(%) of Latin America(developing only) in 2003 to that in 2006?
Your response must be concise. 1.04. What is the ratio of the Gross intake ratio(%) in Burundi in 2003 to that in 2006?
Give a very brief answer. 0.45. What is the ratio of the Gross intake ratio(%) in India in 2003 to that in 2006?
Provide a succinct answer. 0.99. What is the ratio of the Gross intake ratio(%) of Montenegro in 2003 to that in 2006?
Make the answer very short. 0.86. What is the ratio of the Gross intake ratio(%) in Latin America(developing only) in 2003 to that in 2007?
Provide a succinct answer. 1.05. What is the ratio of the Gross intake ratio(%) in Burundi in 2003 to that in 2007?
Provide a short and direct response. 0.53. What is the ratio of the Gross intake ratio(%) in India in 2003 to that in 2007?
Your answer should be very brief. 1.01. What is the ratio of the Gross intake ratio(%) in Montenegro in 2003 to that in 2007?
Offer a very short reply. 0.89. What is the ratio of the Gross intake ratio(%) of Latin America(developing only) in 2004 to that in 2005?
Keep it short and to the point. 1.03. What is the ratio of the Gross intake ratio(%) of Burundi in 2004 to that in 2005?
Offer a very short reply. 1.02. What is the ratio of the Gross intake ratio(%) in India in 2004 to that in 2005?
Give a very brief answer. 1.01. What is the ratio of the Gross intake ratio(%) of Montenegro in 2004 to that in 2005?
Your answer should be compact. 0.86. What is the ratio of the Gross intake ratio(%) in Latin America(developing only) in 2004 to that in 2006?
Offer a terse response. 1.05. What is the ratio of the Gross intake ratio(%) in Burundi in 2004 to that in 2006?
Your response must be concise. 0.5. What is the ratio of the Gross intake ratio(%) of Montenegro in 2004 to that in 2006?
Your answer should be very brief. 0.83. What is the ratio of the Gross intake ratio(%) of Latin America(developing only) in 2004 to that in 2007?
Offer a very short reply. 1.06. What is the ratio of the Gross intake ratio(%) in Burundi in 2004 to that in 2007?
Give a very brief answer. 0.6. What is the ratio of the Gross intake ratio(%) in India in 2004 to that in 2007?
Your answer should be very brief. 1.02. What is the ratio of the Gross intake ratio(%) of Montenegro in 2004 to that in 2007?
Provide a succinct answer. 0.85. What is the ratio of the Gross intake ratio(%) in Latin America(developing only) in 2005 to that in 2006?
Your answer should be very brief. 1.02. What is the ratio of the Gross intake ratio(%) in Burundi in 2005 to that in 2006?
Give a very brief answer. 0.49. What is the ratio of the Gross intake ratio(%) in India in 2005 to that in 2006?
Provide a short and direct response. 0.99. What is the ratio of the Gross intake ratio(%) in Montenegro in 2005 to that in 2006?
Make the answer very short. 0.96. What is the ratio of the Gross intake ratio(%) in Latin America(developing only) in 2005 to that in 2007?
Your answer should be compact. 1.03. What is the ratio of the Gross intake ratio(%) in Burundi in 2005 to that in 2007?
Ensure brevity in your answer.  0.58. What is the ratio of the Gross intake ratio(%) in India in 2005 to that in 2007?
Make the answer very short. 1.01. What is the ratio of the Gross intake ratio(%) in Montenegro in 2005 to that in 2007?
Give a very brief answer. 0.99. What is the ratio of the Gross intake ratio(%) of Latin America(developing only) in 2006 to that in 2007?
Provide a short and direct response. 1.01. What is the ratio of the Gross intake ratio(%) in Burundi in 2006 to that in 2007?
Offer a very short reply. 1.19. What is the ratio of the Gross intake ratio(%) in India in 2006 to that in 2007?
Give a very brief answer. 1.02. What is the ratio of the Gross intake ratio(%) in Montenegro in 2006 to that in 2007?
Give a very brief answer. 1.03. What is the difference between the highest and the second highest Gross intake ratio(%) of Latin America(developing only)?
Your answer should be compact. 0.58. What is the difference between the highest and the second highest Gross intake ratio(%) in Burundi?
Your response must be concise. 26.24. What is the difference between the highest and the second highest Gross intake ratio(%) in India?
Provide a short and direct response. 0.03. What is the difference between the highest and the second highest Gross intake ratio(%) in Montenegro?
Your answer should be very brief. 3.8. What is the difference between the highest and the lowest Gross intake ratio(%) of Latin America(developing only)?
Make the answer very short. 8.87. What is the difference between the highest and the lowest Gross intake ratio(%) in Burundi?
Give a very brief answer. 100.12. What is the difference between the highest and the lowest Gross intake ratio(%) in India?
Your answer should be very brief. 20.36. What is the difference between the highest and the lowest Gross intake ratio(%) in Montenegro?
Provide a succinct answer. 31.58. 